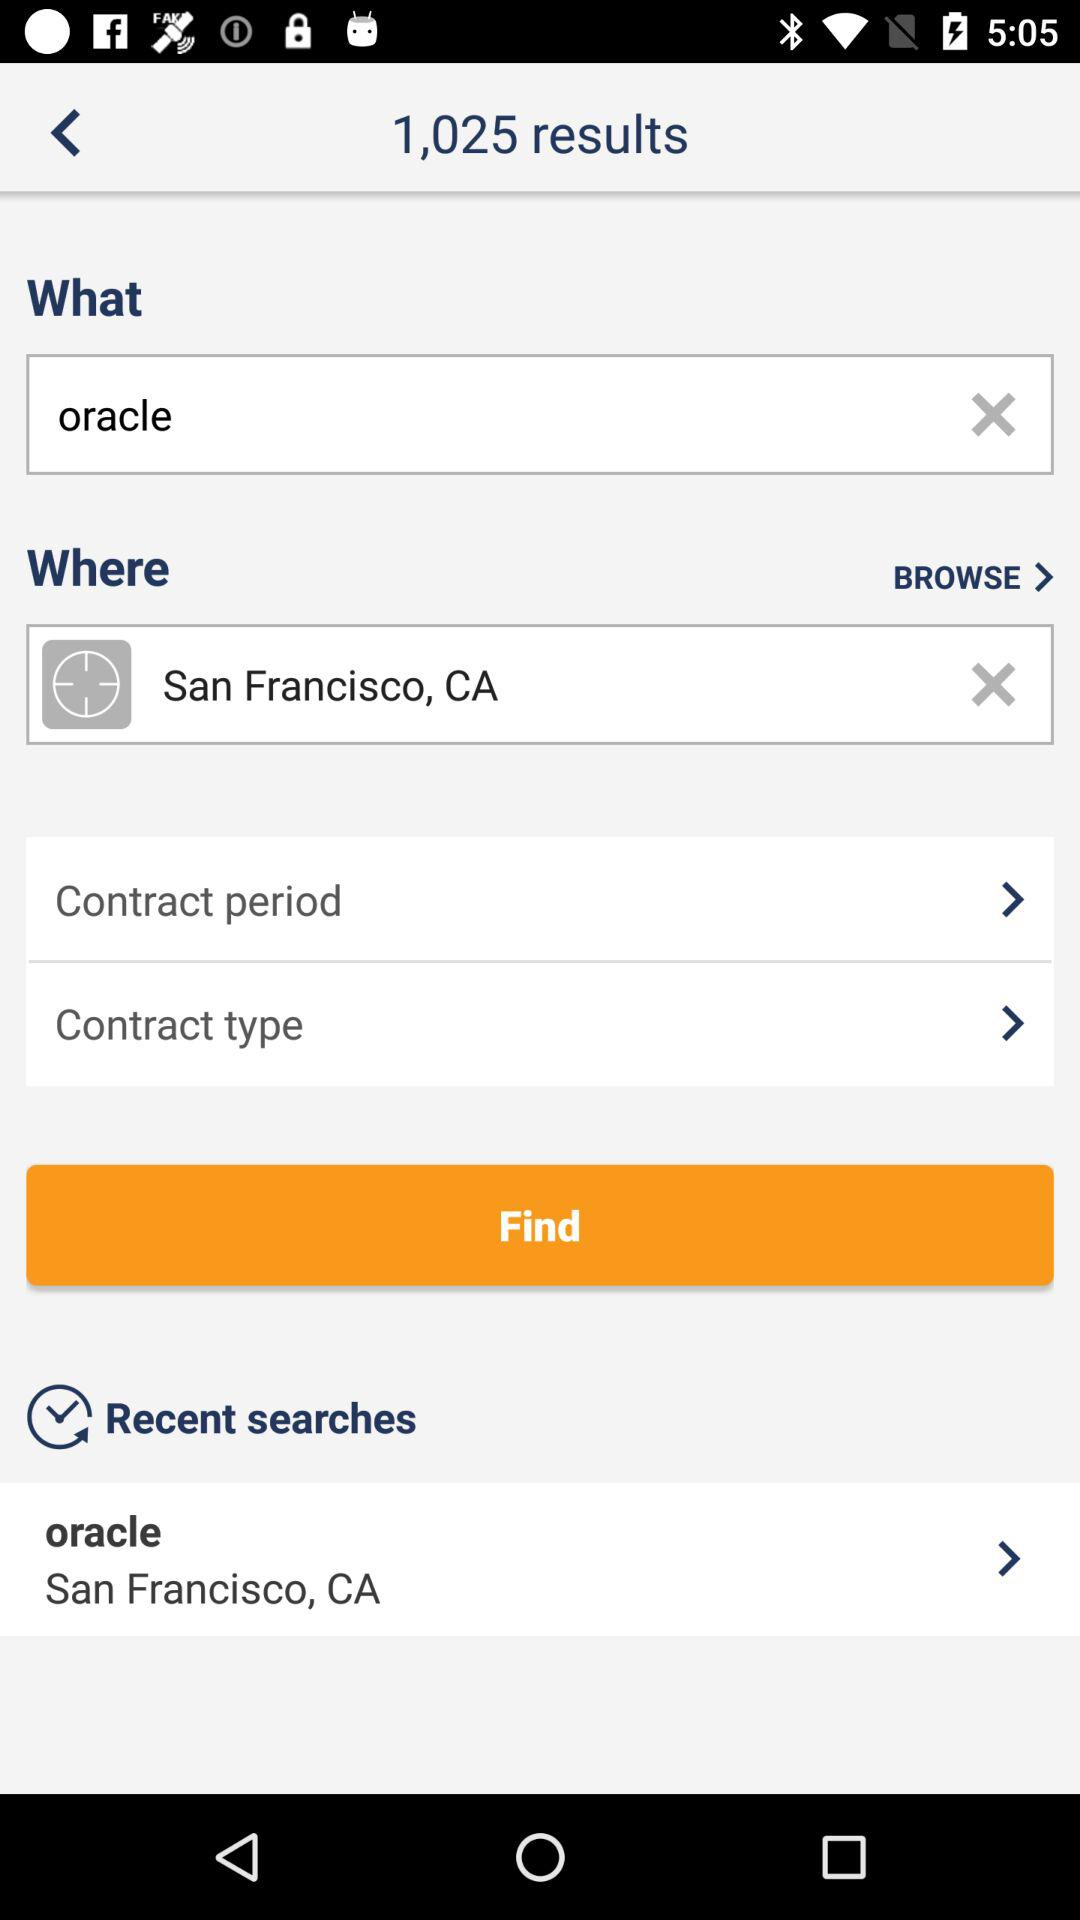How many results are there for "oracle"? There are 1,025 results for "oracle". 